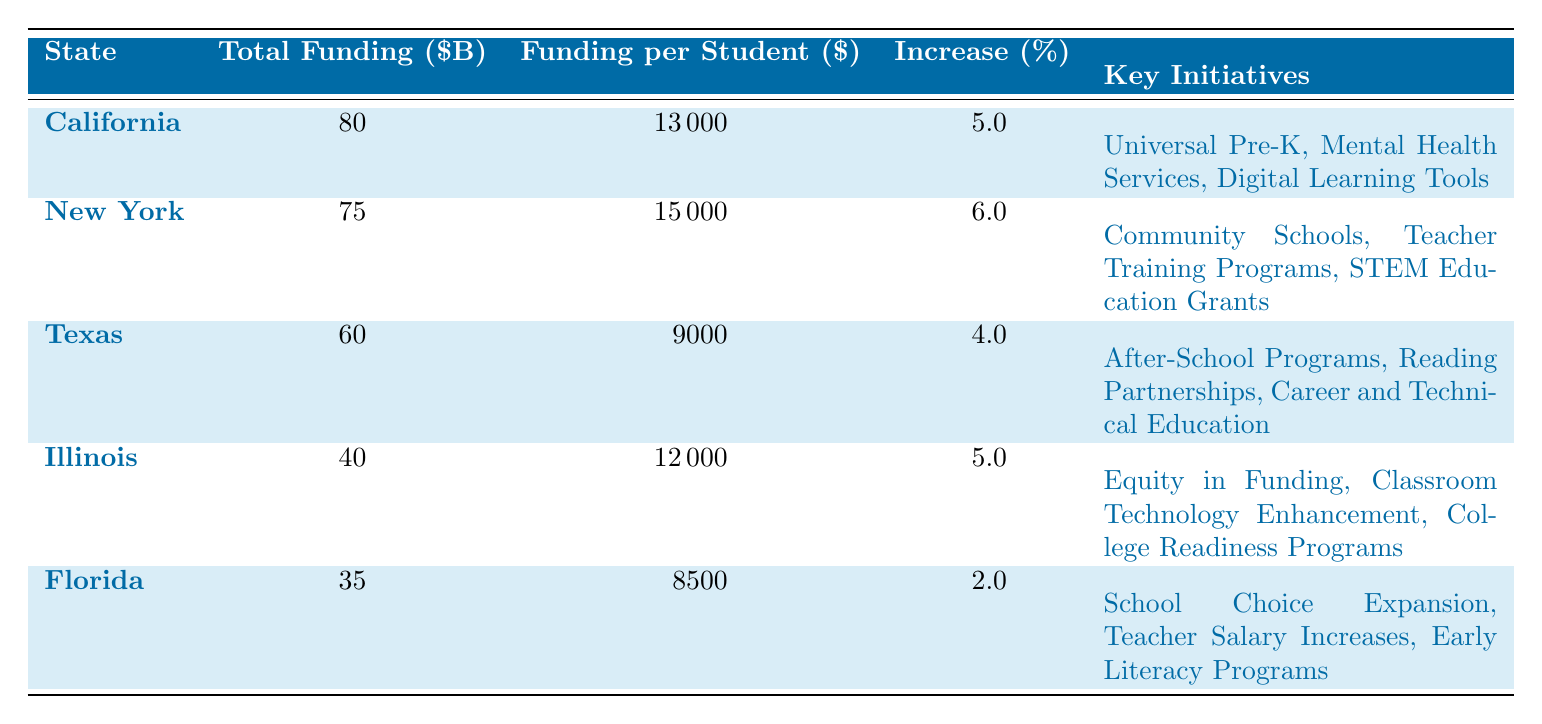What state has the highest total funding allocation? Referring to the total funding column, California has the highest total funding allocation of 80 billion USD.
Answer: California How much is the funding per student in New York? From the funding per student column, New York has a funding allocation of 15,000 USD per student.
Answer: 15,000 Which state has the lowest percentage increase in funding? By observing the percentage increase column, Florida has the lowest percentage increase at 2%.
Answer: Florida What is the total funding allocated for public education initiatives in Illinois and Texas combined? To find the total for Illinois and Texas, we add their total funding: 40 billion (Illinois) + 60 billion (Texas) = 100 billion.
Answer: 100 billion Is there a state that allocated funding for both mental health services and early literacy programs? By checking the key initiatives for California and Florida, California has mental health services while Florida has early literacy programs, but there is no overlap in their initiatives. Therefore, the answer is no.
Answer: No What is the average funding per student among the five states? To find the average, we sum the funding per student: 13,000 (California) + 15,000 (New York) + 9,000 (Texas) + 12,000 (Illinois) + 8,500 (Florida) = 57,500. Then we divide by the number of states: 57,500 / 5 = 11,500.
Answer: 11,500 Does Texas allocate more total funding than Florida? Checking the total funding for Texas (60 billion) and Florida (35 billion), we see that Texas has significantly more funding. Therefore, the answer is yes.
Answer: Yes Which state has key initiatives focused on STEM education? By looking at the key initiatives, New York focuses on STEM education grants, indicating that they have initiatives related to this area.
Answer: New York 